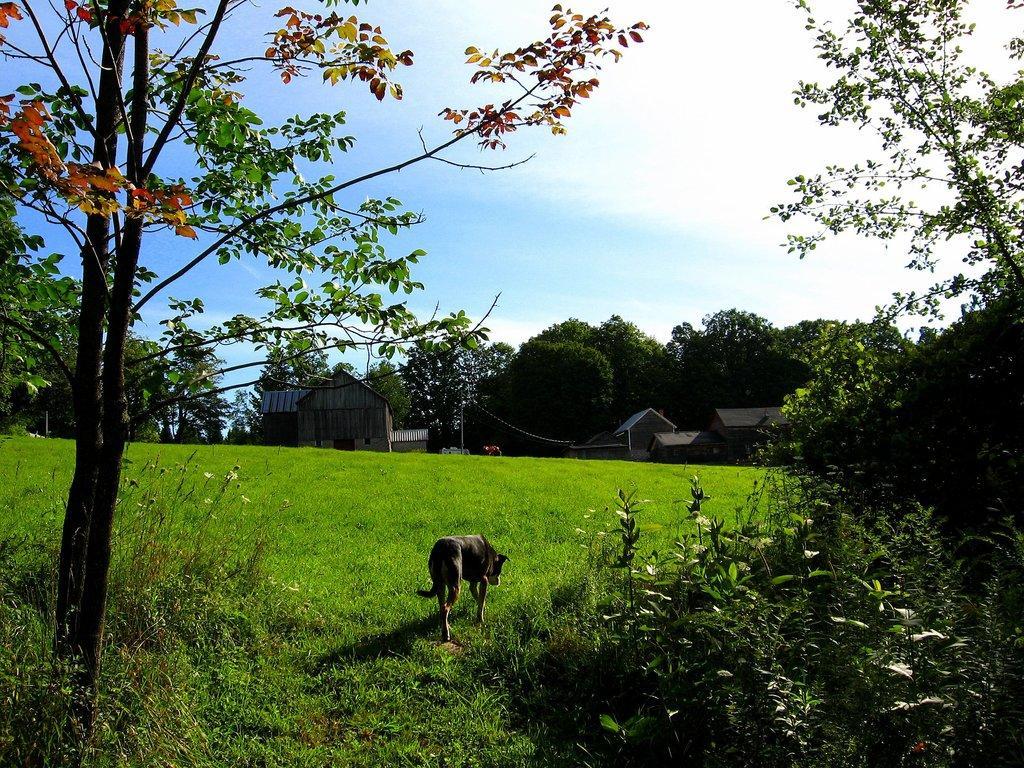Could you give a brief overview of what you see in this image? In this image we can see the trees and a dog on the grass. And there are houses and sky in the background. 